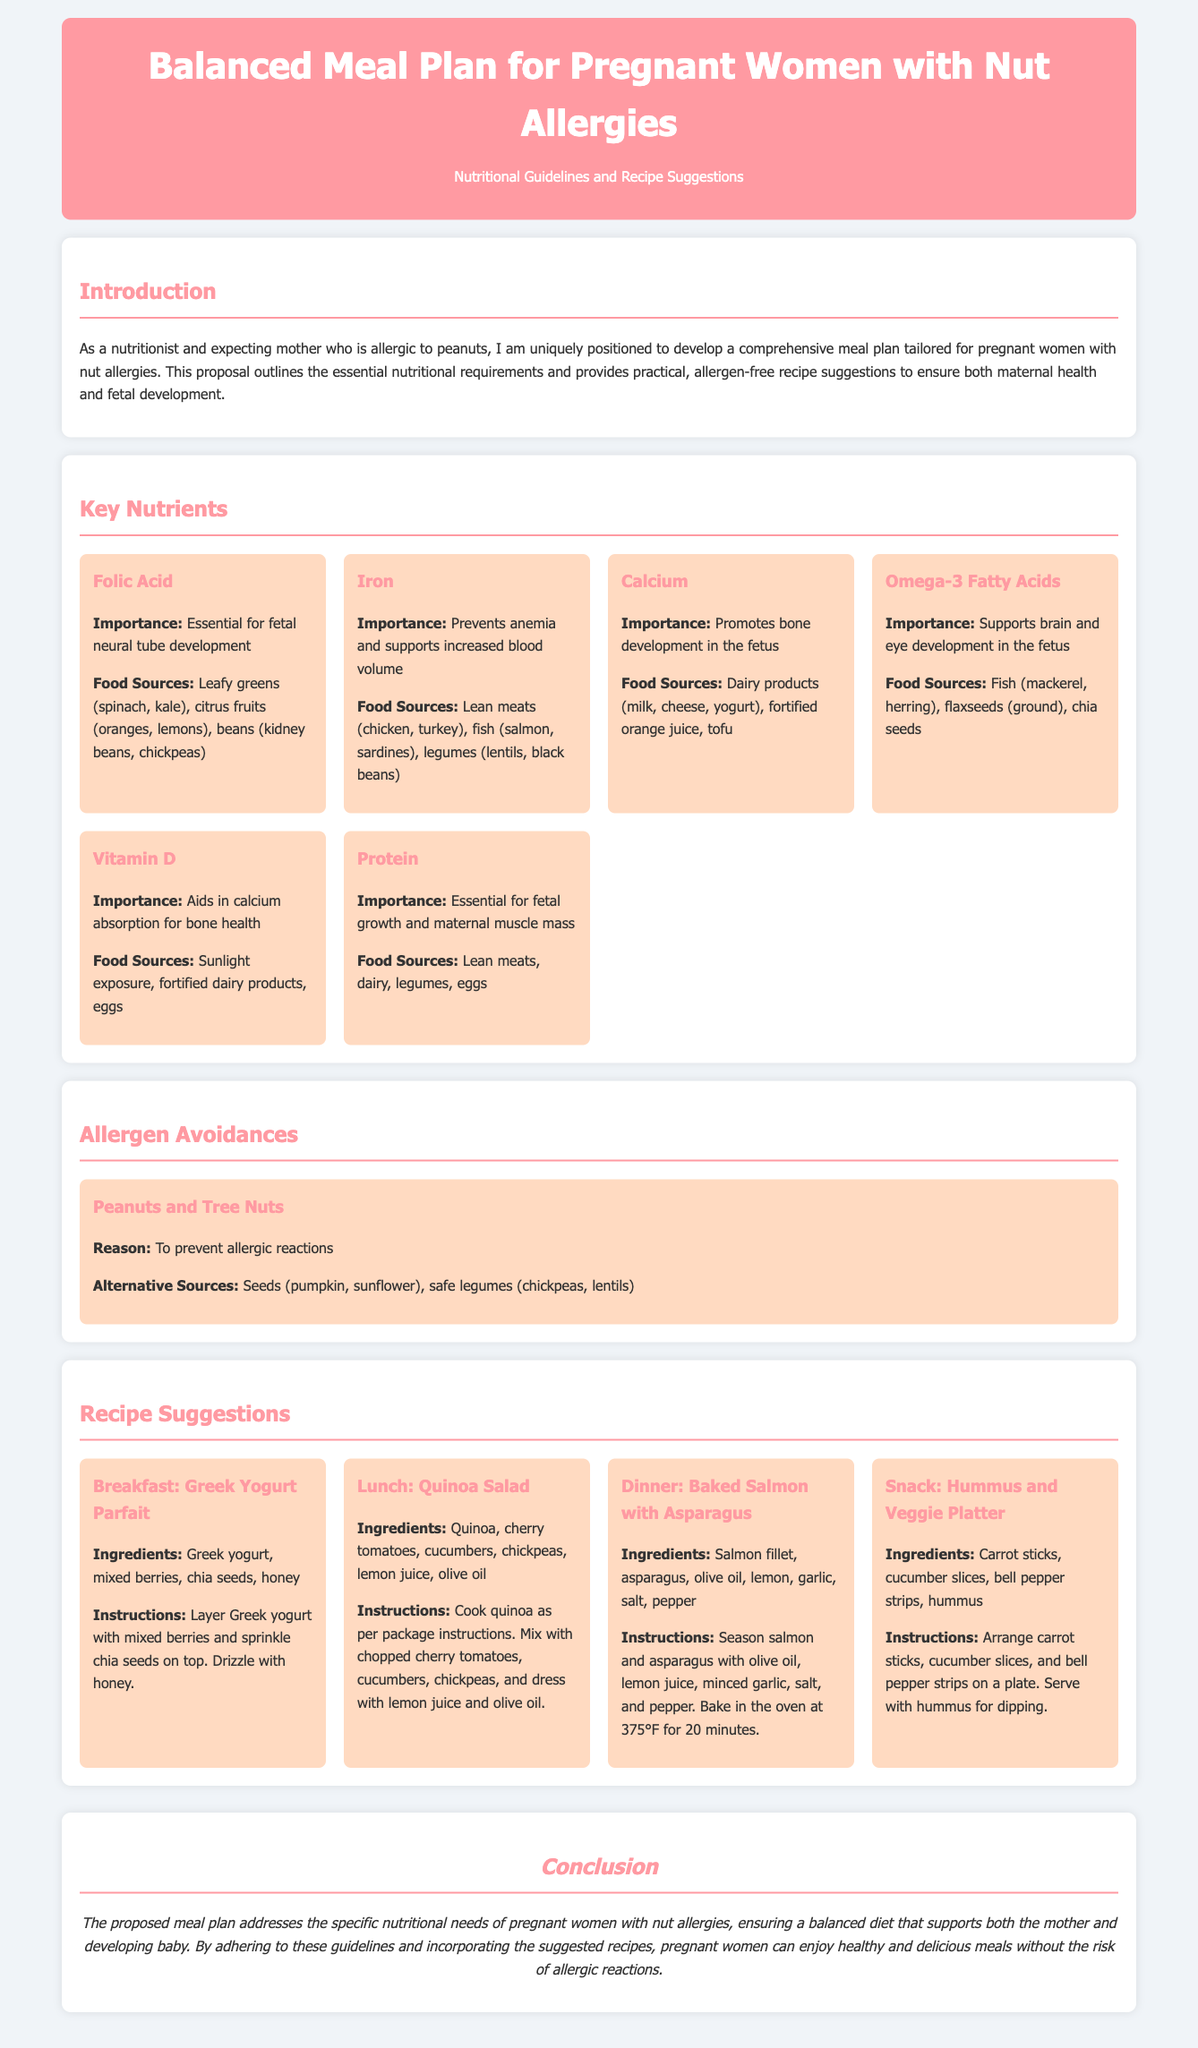What is the title of the proposal? The title of the proposal is stated at the top of the document.
Answer: Balanced Meal Plan for Pregnant Women with Nut Allergies How many key nutrients are listed in the proposal? The proposal lists essential nutrients needed for pregnant women, which can be counted in the Key Nutrients section.
Answer: 6 What is an important source of Omega-3 Fatty Acids? The document provides food sources for each nutrient, including Omega-3 Fatty Acids.
Answer: Fish What recipe is suggested for breakfast? The proposal includes specific meal ideas, and one of them is listed under the Recipe Suggestions section.
Answer: Greek Yogurt Parfait What is the reason for avoiding peanuts and tree nuts? The proposal explains the rationale for avoiding certain allergens in the Allergen Avoidances section.
Answer: To prevent allergic reactions Which vitamin aids in calcium absorption? The Key Nutrients section outlines several vitamins and minerals, including Vitamin D.
Answer: Vitamin D What type of diet does the proposal emphasize for pregnant women with nut allergies? The proposal indicates the overall focus of the meal plan to ensure safety and nutritional balance for targeted audiences.
Answer: Balanced diet What is the importance of Folic Acid mentioned in the document? The document underlines the roles of different nutrients, specifically stating the importance of Folic Acid.
Answer: Essential for fetal neural tube development 